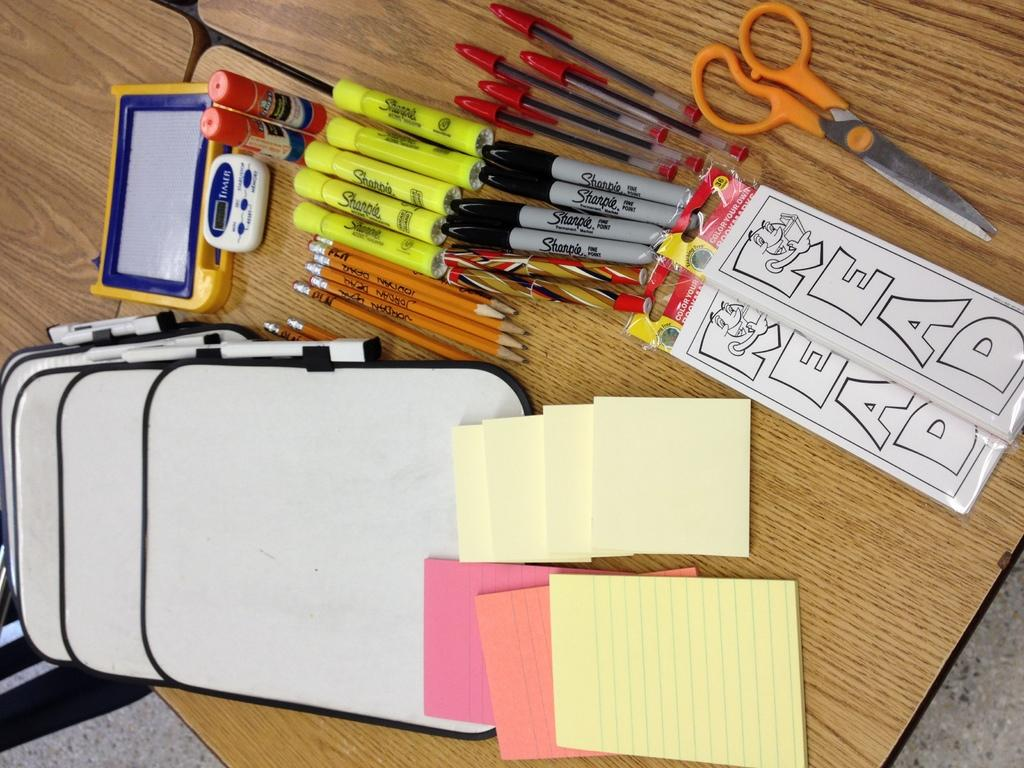<image>
Offer a succinct explanation of the picture presented. Many stationary items are on a desk including some bookmarks that say "read" on them. 